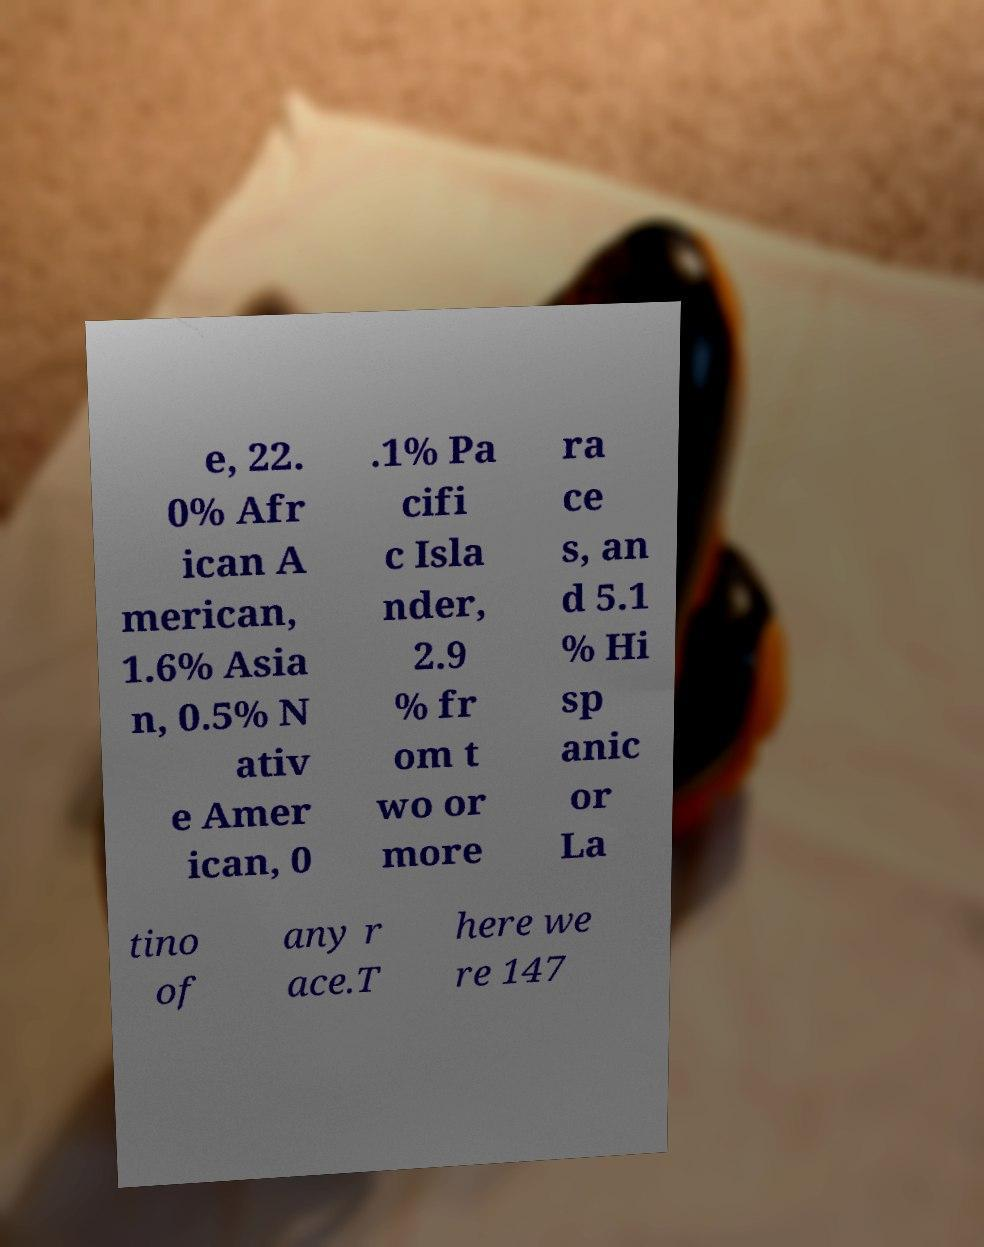Can you accurately transcribe the text from the provided image for me? e, 22. 0% Afr ican A merican, 1.6% Asia n, 0.5% N ativ e Amer ican, 0 .1% Pa cifi c Isla nder, 2.9 % fr om t wo or more ra ce s, an d 5.1 % Hi sp anic or La tino of any r ace.T here we re 147 